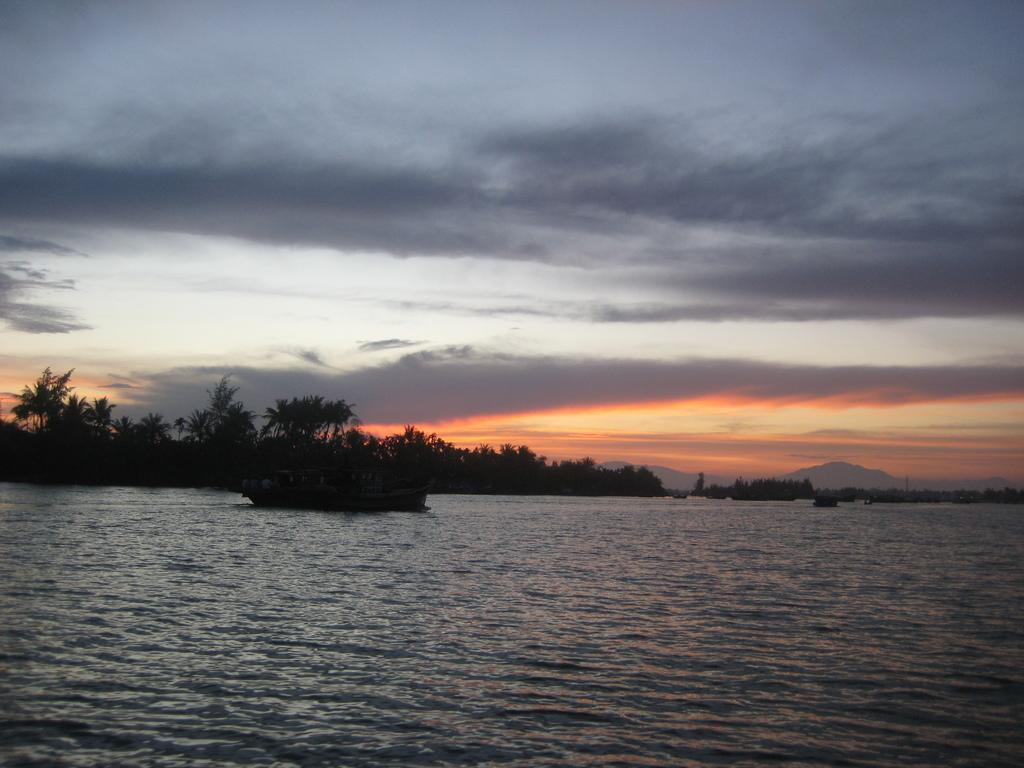What is the main subject of the image? There is a boat in the image. Where is the boat located? The boat is in the water. What can be seen in the background of the image? There are trees, mountains, and the sky visible in the background of the image. Can you describe the setting of the image? The image might have been taken in the ocean, given the presence of water and the boat. How many roses are on the baby's swing in the image? There are no roses, babies, or swings present in the image; it features a boat in the water with a background of trees, mountains, and the sky. 